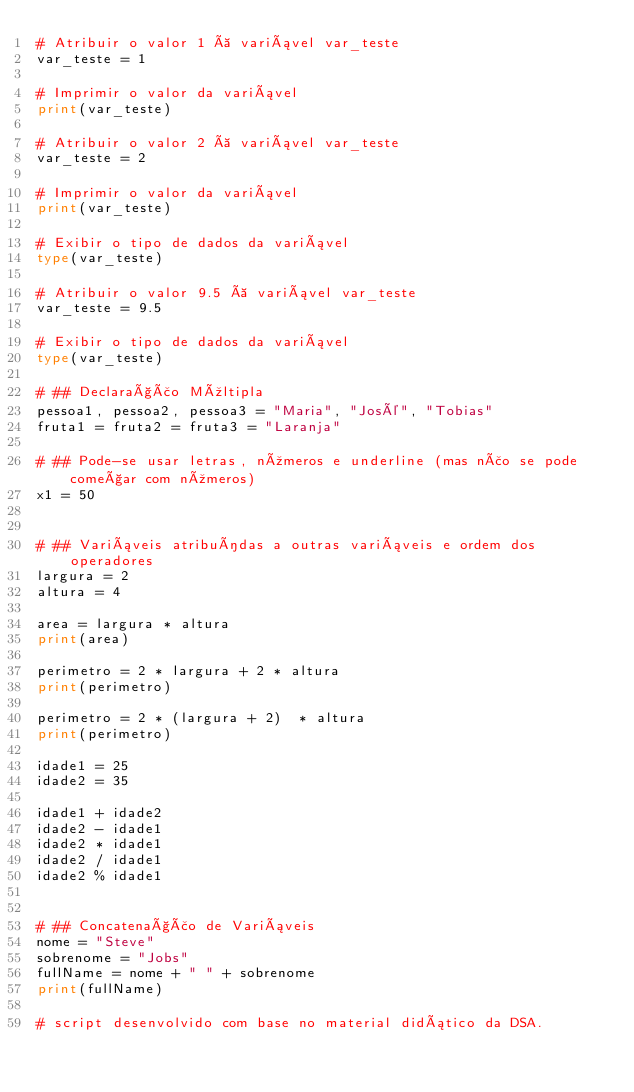<code> <loc_0><loc_0><loc_500><loc_500><_Python_># Atribuir o valor 1 à variável var_teste
var_teste = 1

# Imprimir o valor da variável
print(var_teste)

# Atribuir o valor 2 à variável var_teste
var_teste = 2

# Imprimir o valor da variável
print(var_teste)

# Exibir o tipo de dados da variável
type(var_teste)

# Atribuir o valor 9.5 à variável var_teste
var_teste = 9.5

# Exibir o tipo de dados da variável
type(var_teste)

# ## Declaração Múltipla
pessoa1, pessoa2, pessoa3 = "Maria", "José", "Tobias"
fruta1 = fruta2 = fruta3 = "Laranja"

# ## Pode-se usar letras, números e underline (mas não se pode começar com números)
x1 = 50


# ## Variáveis atribuídas a outras variáveis e ordem dos operadores
largura = 2
altura = 4

area = largura * altura
print(area)

perimetro = 2 * largura + 2 * altura
print(perimetro)

perimetro = 2 * (largura + 2)  * altura
print(perimetro)

idade1 = 25
idade2 = 35

idade1 + idade2
idade2 - idade1
idade2 * idade1
idade2 / idade1
idade2 % idade1


# ## Concatenação de Variáveis
nome = "Steve"
sobrenome = "Jobs"
fullName = nome + " " + sobrenome
print(fullName)

# script desenvolvido com base no material didático da DSA.
</code> 